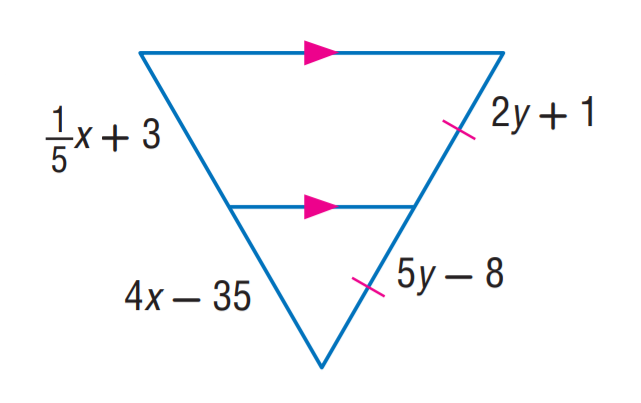Answer the mathemtical geometry problem and directly provide the correct option letter.
Question: Find y.
Choices: A: 1 B: 3 C: 5 D: 8 B 